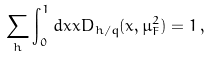Convert formula to latex. <formula><loc_0><loc_0><loc_500><loc_500>\sum _ { h } \int _ { 0 } ^ { 1 } d x x D _ { h / q } ( x , \mu _ { F } ^ { 2 } ) = 1 \, ,</formula> 